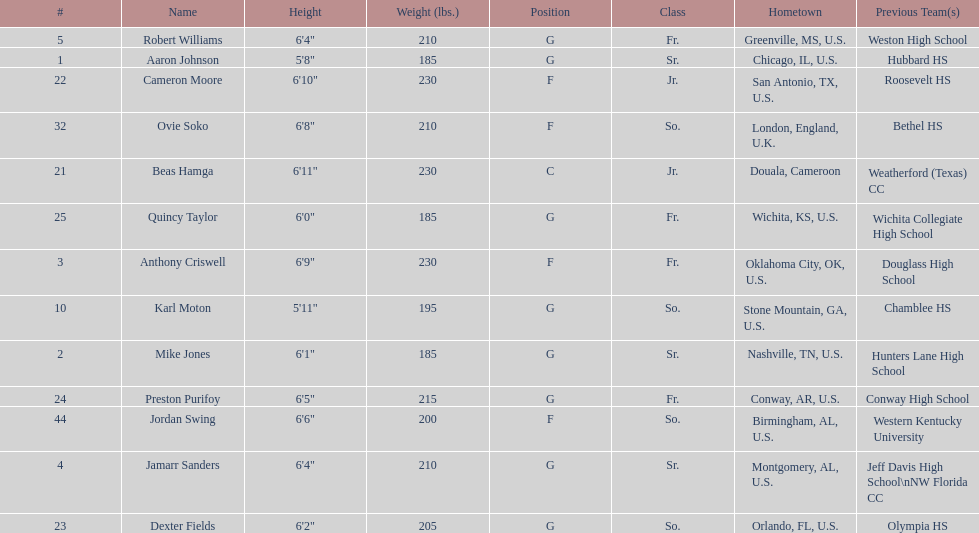What is the count of juniors in the team? 2. 